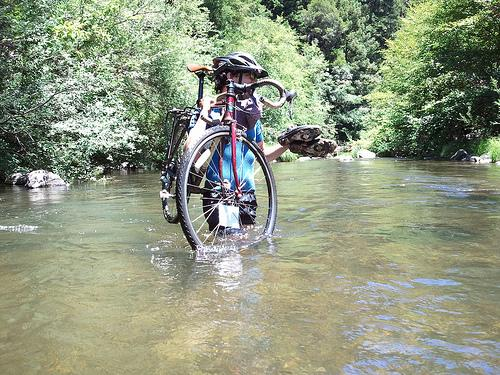Choose a caption that best describes the main action in the image and mention two aspects of the man's appearance. Man carrying bike through water. Man has blue shirt and is wearing glasses. As a reference for someone trying to find this image, describe the main action, the man's appearance, and the environment. Look for an image of a man carrying a bike through water, wearing a blue shirt and glasses, amidst a forest with green trees and a stream. Which caption describes a detail related to bike equipment, and what color is the bike's seat according to the text? A reflector in bike spokes. The bike's seat is orange. For a biking gear advertisement, describe the appearance of the helmet and the bike seat. The helmet is silver and black, and the bike seat is orange. Identify the main activity taking place in the image and list three objects involved in it. A man is carrying a bike through the water. The objects involved are a bike, a pair of shoes, and a helmet. Narrate a short scene that could happen in the image including at least four objects present in it. A man wearing a blue shirt, sunglasses, and a helmet carries his bike with red frame and orange seat across a calm stream amid a forest. What kind of environment is pictured in the image and what color is the man's shirt? The environment is a forest with a stream and the man's shirt is blue. Find a caption that describes the man's location and activity in the image, and provide two details about his bike. Man walking in the river with a bike. The bike has a red frame and thick mountain bike wheels. Imagine you are the person in the image. What would you say to someone who asks how you're feeling while performing the action in the image? I feel a bit cold from the water, but I am determined to get my bike across this stream with me. In a multiple-choice visual question task, provide a correct answer for the color of the bike's frame and the man's shirt. The bike's frame is red, and the man's shirt is blue. 